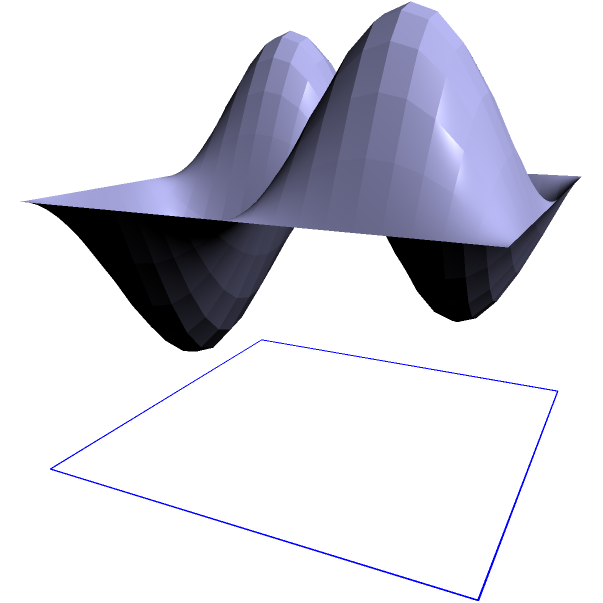As a musician working on guitar design, you need to calculate the volume of a guitar body. The body's shape can be approximated by the surface $z = 0.5 + 0.3\sin(2\pi x)\sin(2\pi y)$ over the region $0 \leq x \leq 1$ and $0 \leq y \leq 1$. Calculate the volume of this guitar body using a double integral. To find the volume under a surface $z = f(x,y)$ over a region R, we use the double integral:

$$V = \int\int_R f(x,y) \, dA$$

In this case, $f(x,y) = 0.5 + 0.3\sin(2\pi x)\sin(2\pi y)$ and $R$ is the square region $[0,1] \times [0,1]$.

Steps:
1) Set up the double integral:
   $$V = \int_0^1 \int_0^1 [0.5 + 0.3\sin(2\pi x)\sin(2\pi y)] \, dy \, dx$$

2) Integrate with respect to y:
   $$V = \int_0^1 \left[0.5y - \frac{0.3}{2\pi}\cos(2\pi y)\sin(2\pi x)\right]_0^1 \, dx$$
   $$= \int_0^1 \left[0.5 - \frac{0.3}{2\pi}\cos(2\pi)\sin(2\pi x) + \frac{0.3}{2\pi}\sin(2\pi x)\right] \, dx$$
   $$= \int_0^1 0.5 \, dx$$ (since $\cos(2\pi) = 1$ and the sine terms cancel)

3) Integrate with respect to x:
   $$V = [0.5x]_0^1 = 0.5$$

Therefore, the volume of the guitar body is 0.5 cubic units.
Answer: 0.5 cubic units 